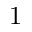<formula> <loc_0><loc_0><loc_500><loc_500>1</formula> 